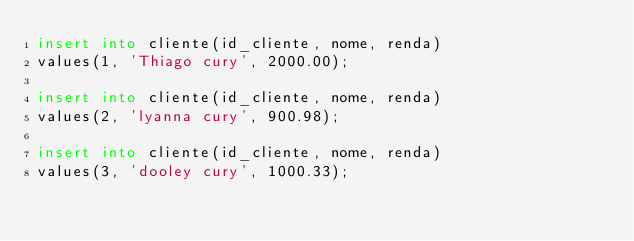<code> <loc_0><loc_0><loc_500><loc_500><_SQL_>insert into cliente(id_cliente, nome, renda)
values(1, 'Thiago cury', 2000.00);

insert into cliente(id_cliente, nome, renda)
values(2, 'lyanna cury', 900.98);

insert into cliente(id_cliente, nome, renda)
values(3, 'dooley cury', 1000.33);
</code> 